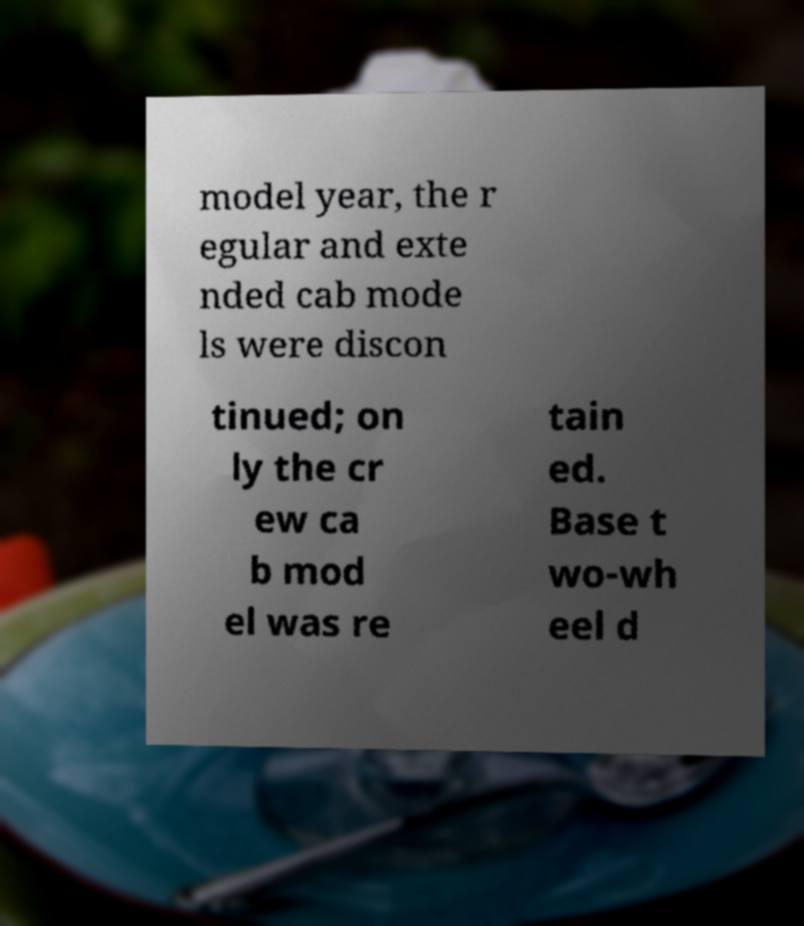For documentation purposes, I need the text within this image transcribed. Could you provide that? model year, the r egular and exte nded cab mode ls were discon tinued; on ly the cr ew ca b mod el was re tain ed. Base t wo-wh eel d 